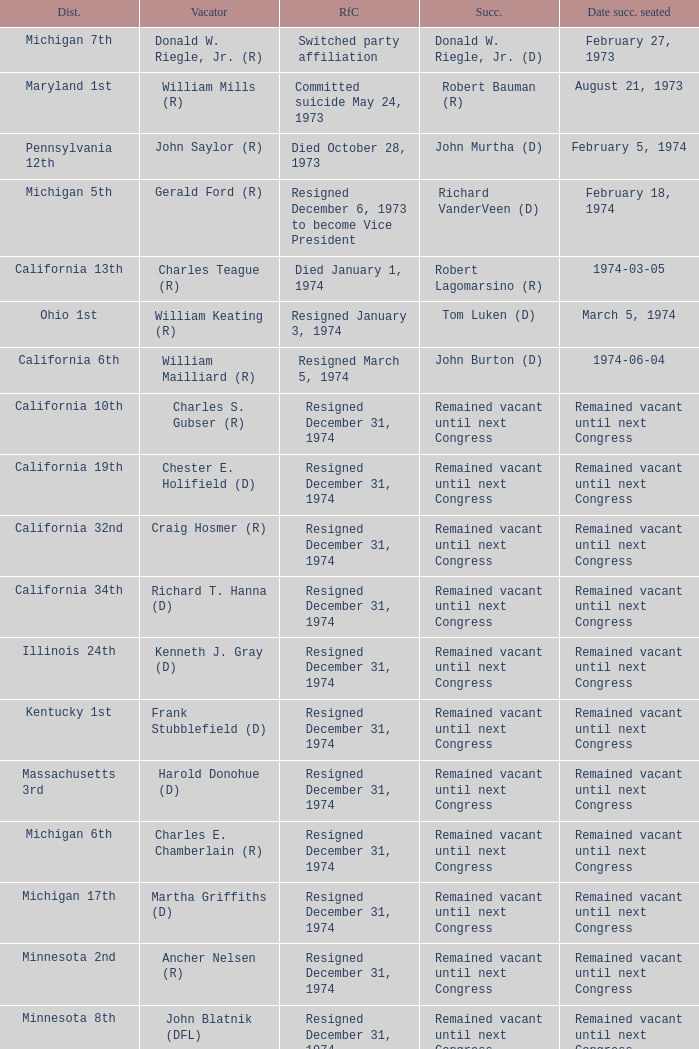When was the date successor seated when the vacator was charles e. chamberlain (r)? Remained vacant until next Congress. 